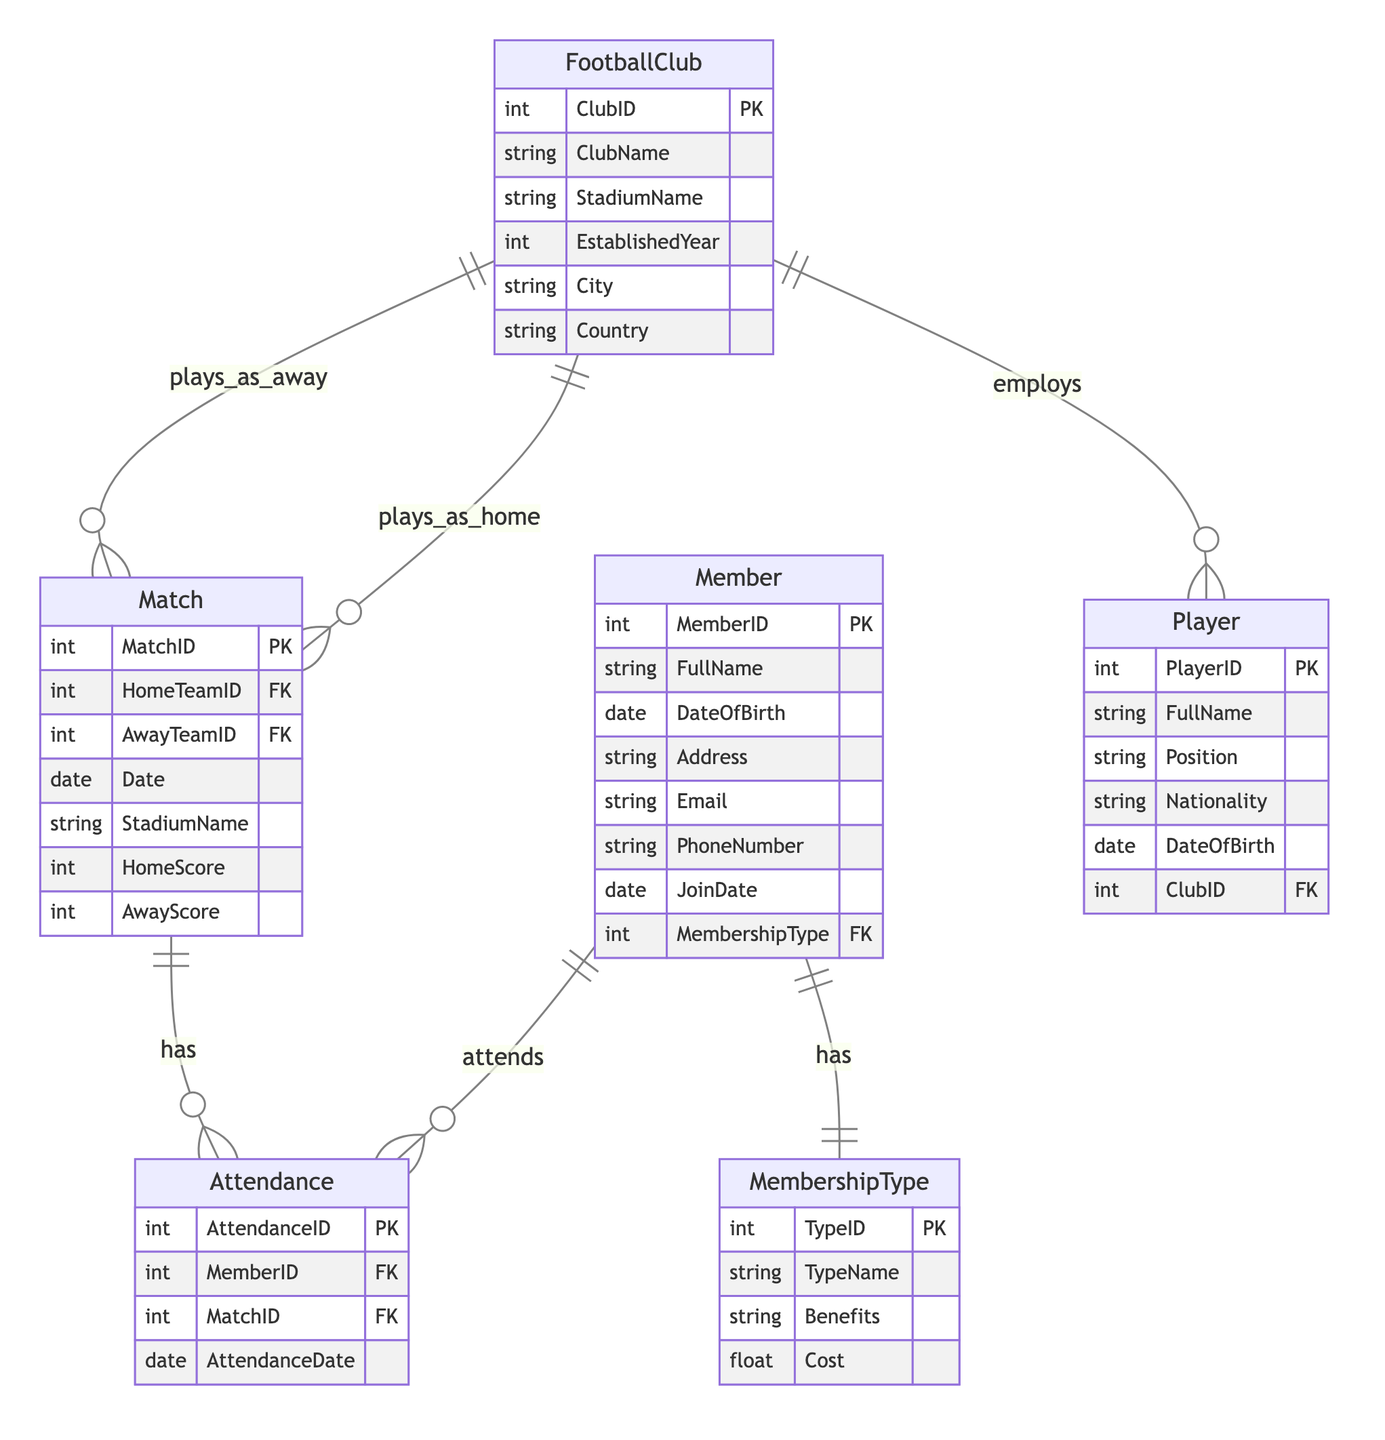What's the primary key for the Member entity? The primary key for the Member entity is MemberID, which uniquely identifies each member in the Membership Management system.
Answer: MemberID How many entities are present in the diagram? The diagram outlines five entities: Member, MembershipType, FootballClub, Player, and Match. Counting these gives us a total of five entities.
Answer: Five What is the relationship between Member and Match? The relationship between Member and Match is called Attendance. It indicates that members attend matches, and this is represented by the Attendance entity linking both.
Answer: Attendance Which entity represents the cost associated with a membership type? The MembershipType entity has an attribute called Cost that represents the financial aspect associated with different membership types.
Answer: Cost What type of relationship exists between FootballClub and Player? The relationship between FootballClub and Player is an employment relationship, indicating that a club employs players, which can be inferred from the direction (one-to-many).
Answer: employs How many attributes does the Match entity have? The Match entity contains six attributes: MatchID, HomeTeamID, AwayTeamID, Date, StadiumName, HomeScore, and AwayScore, totaling six attributes.
Answer: Six What does the Attendance entity link? The Attendance entity links Member and Match, referencing which members attended specific matches, creating a connection between members and the matches they attended.
Answer: Member and Match Which entity includes the attribute FullName? Both the Member and Player entities include the FullName attribute, identifying the names of the members and players respectively.
Answer: Member and Player What is the primary key of the Match entity? The primary key of the Match entity is MatchID, which uniquely identifies each match in the management system.
Answer: MatchID 